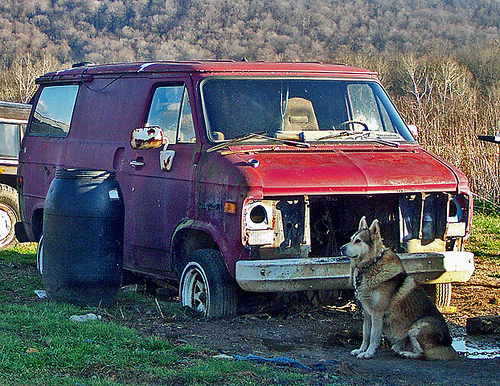<image>
Is the dog in front of the van? Yes. The dog is positioned in front of the van, appearing closer to the camera viewpoint. 